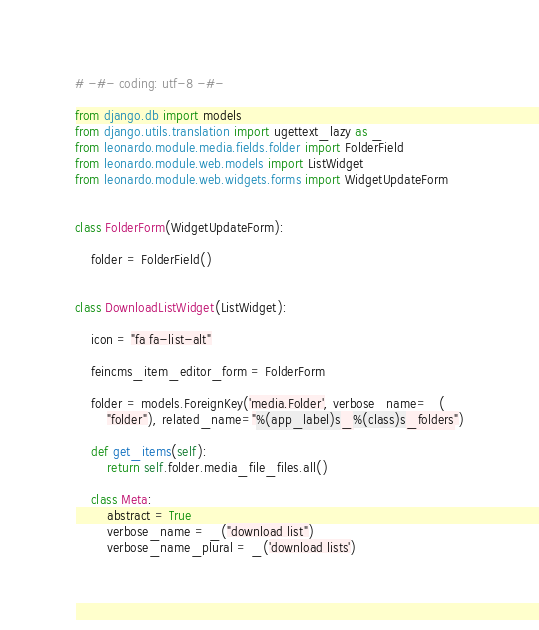Convert code to text. <code><loc_0><loc_0><loc_500><loc_500><_Python_># -#- coding: utf-8 -#-

from django.db import models
from django.utils.translation import ugettext_lazy as _
from leonardo.module.media.fields.folder import FolderField
from leonardo.module.web.models import ListWidget
from leonardo.module.web.widgets.forms import WidgetUpdateForm


class FolderForm(WidgetUpdateForm):

    folder = FolderField()


class DownloadListWidget(ListWidget):

    icon = "fa fa-list-alt"

    feincms_item_editor_form = FolderForm

    folder = models.ForeignKey('media.Folder', verbose_name=_(
        "folder"), related_name="%(app_label)s_%(class)s_folders")

    def get_items(self):
        return self.folder.media_file_files.all()

    class Meta:
        abstract = True
        verbose_name = _("download list")
        verbose_name_plural = _('download lists')
</code> 